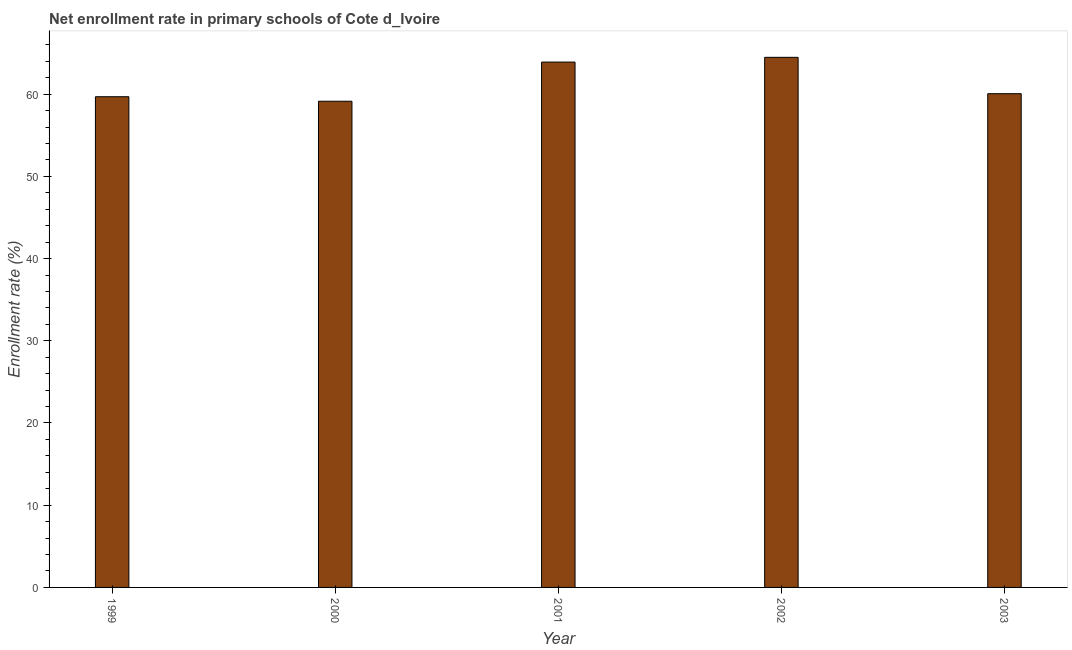Does the graph contain grids?
Keep it short and to the point. No. What is the title of the graph?
Provide a short and direct response. Net enrollment rate in primary schools of Cote d_Ivoire. What is the label or title of the X-axis?
Provide a short and direct response. Year. What is the label or title of the Y-axis?
Provide a short and direct response. Enrollment rate (%). What is the net enrollment rate in primary schools in 2000?
Provide a short and direct response. 59.14. Across all years, what is the maximum net enrollment rate in primary schools?
Keep it short and to the point. 64.48. Across all years, what is the minimum net enrollment rate in primary schools?
Keep it short and to the point. 59.14. What is the sum of the net enrollment rate in primary schools?
Your answer should be very brief. 307.25. What is the difference between the net enrollment rate in primary schools in 1999 and 2003?
Give a very brief answer. -0.37. What is the average net enrollment rate in primary schools per year?
Make the answer very short. 61.45. What is the median net enrollment rate in primary schools?
Your answer should be compact. 60.05. In how many years, is the net enrollment rate in primary schools greater than 16 %?
Provide a short and direct response. 5. What is the ratio of the net enrollment rate in primary schools in 2000 to that in 2001?
Offer a very short reply. 0.93. Is the difference between the net enrollment rate in primary schools in 1999 and 2001 greater than the difference between any two years?
Make the answer very short. No. What is the difference between the highest and the second highest net enrollment rate in primary schools?
Offer a terse response. 0.58. What is the difference between the highest and the lowest net enrollment rate in primary schools?
Ensure brevity in your answer.  5.34. In how many years, is the net enrollment rate in primary schools greater than the average net enrollment rate in primary schools taken over all years?
Give a very brief answer. 2. Are all the bars in the graph horizontal?
Offer a very short reply. No. What is the difference between two consecutive major ticks on the Y-axis?
Ensure brevity in your answer.  10. What is the Enrollment rate (%) in 1999?
Your answer should be very brief. 59.69. What is the Enrollment rate (%) in 2000?
Make the answer very short. 59.14. What is the Enrollment rate (%) in 2001?
Keep it short and to the point. 63.9. What is the Enrollment rate (%) of 2002?
Give a very brief answer. 64.48. What is the Enrollment rate (%) in 2003?
Provide a succinct answer. 60.05. What is the difference between the Enrollment rate (%) in 1999 and 2000?
Provide a succinct answer. 0.55. What is the difference between the Enrollment rate (%) in 1999 and 2001?
Make the answer very short. -4.21. What is the difference between the Enrollment rate (%) in 1999 and 2002?
Your answer should be very brief. -4.79. What is the difference between the Enrollment rate (%) in 1999 and 2003?
Give a very brief answer. -0.37. What is the difference between the Enrollment rate (%) in 2000 and 2001?
Ensure brevity in your answer.  -4.77. What is the difference between the Enrollment rate (%) in 2000 and 2002?
Your answer should be compact. -5.34. What is the difference between the Enrollment rate (%) in 2000 and 2003?
Your answer should be very brief. -0.92. What is the difference between the Enrollment rate (%) in 2001 and 2002?
Give a very brief answer. -0.58. What is the difference between the Enrollment rate (%) in 2001 and 2003?
Your answer should be very brief. 3.85. What is the difference between the Enrollment rate (%) in 2002 and 2003?
Provide a succinct answer. 4.42. What is the ratio of the Enrollment rate (%) in 1999 to that in 2001?
Give a very brief answer. 0.93. What is the ratio of the Enrollment rate (%) in 1999 to that in 2002?
Ensure brevity in your answer.  0.93. What is the ratio of the Enrollment rate (%) in 1999 to that in 2003?
Make the answer very short. 0.99. What is the ratio of the Enrollment rate (%) in 2000 to that in 2001?
Your answer should be compact. 0.93. What is the ratio of the Enrollment rate (%) in 2000 to that in 2002?
Provide a succinct answer. 0.92. What is the ratio of the Enrollment rate (%) in 2000 to that in 2003?
Make the answer very short. 0.98. What is the ratio of the Enrollment rate (%) in 2001 to that in 2002?
Keep it short and to the point. 0.99. What is the ratio of the Enrollment rate (%) in 2001 to that in 2003?
Offer a terse response. 1.06. What is the ratio of the Enrollment rate (%) in 2002 to that in 2003?
Offer a very short reply. 1.07. 